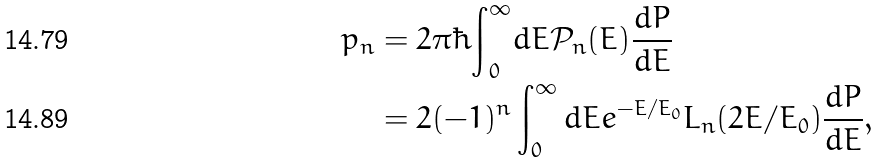Convert formula to latex. <formula><loc_0><loc_0><loc_500><loc_500>p _ { n } & = 2 \pi \hbar { \int } _ { 0 } ^ { \infty } d E \mathcal { P } _ { n } ( E ) \frac { d P } { d E } \\ & = 2 ( - 1 ) ^ { n } \int _ { 0 } ^ { \infty } d E e ^ { - E / E _ { 0 } } L _ { n } ( 2 E / E _ { 0 } ) \frac { d P } { d E } ,</formula> 